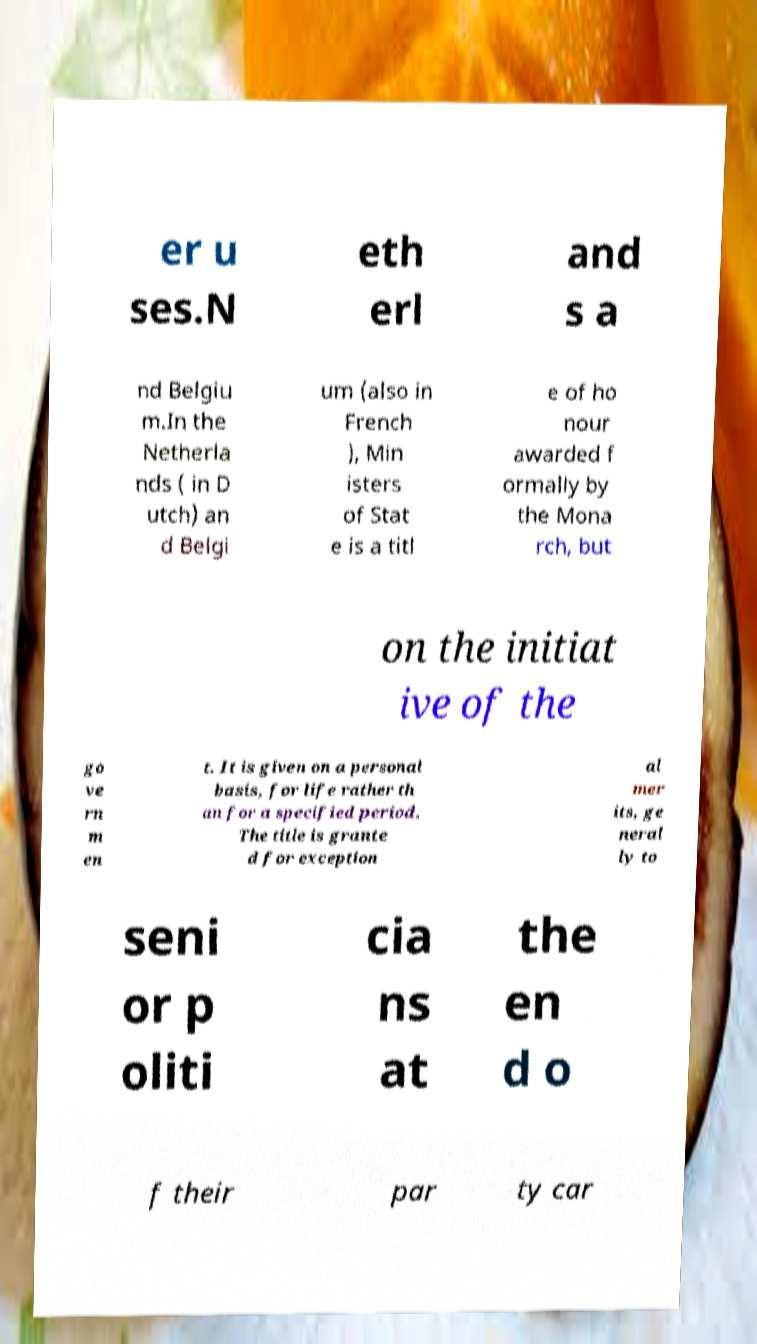There's text embedded in this image that I need extracted. Can you transcribe it verbatim? er u ses.N eth erl and s a nd Belgiu m.In the Netherla nds ( in D utch) an d Belgi um (also in French ), Min isters of Stat e is a titl e of ho nour awarded f ormally by the Mona rch, but on the initiat ive of the go ve rn m en t. It is given on a personal basis, for life rather th an for a specified period. The title is grante d for exception al mer its, ge neral ly to seni or p oliti cia ns at the en d o f their par ty car 